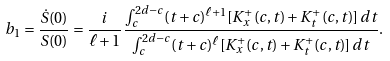Convert formula to latex. <formula><loc_0><loc_0><loc_500><loc_500>b _ { 1 } = \frac { \dot { S } ( 0 ) } { S ( 0 ) } = \frac { i } { \ell + 1 } \frac { \int _ { c } ^ { 2 d - c } ( t + c ) ^ { \ell + 1 } [ K ^ { + } _ { x } ( c , t ) + K ^ { + } _ { t } ( c , t ) ] \, d t } { \int _ { c } ^ { 2 d - c } ( t + c ) ^ { \ell } [ K ^ { + } _ { x } ( c , t ) + K ^ { + } _ { t } ( c , t ) ] \, d t } .</formula> 